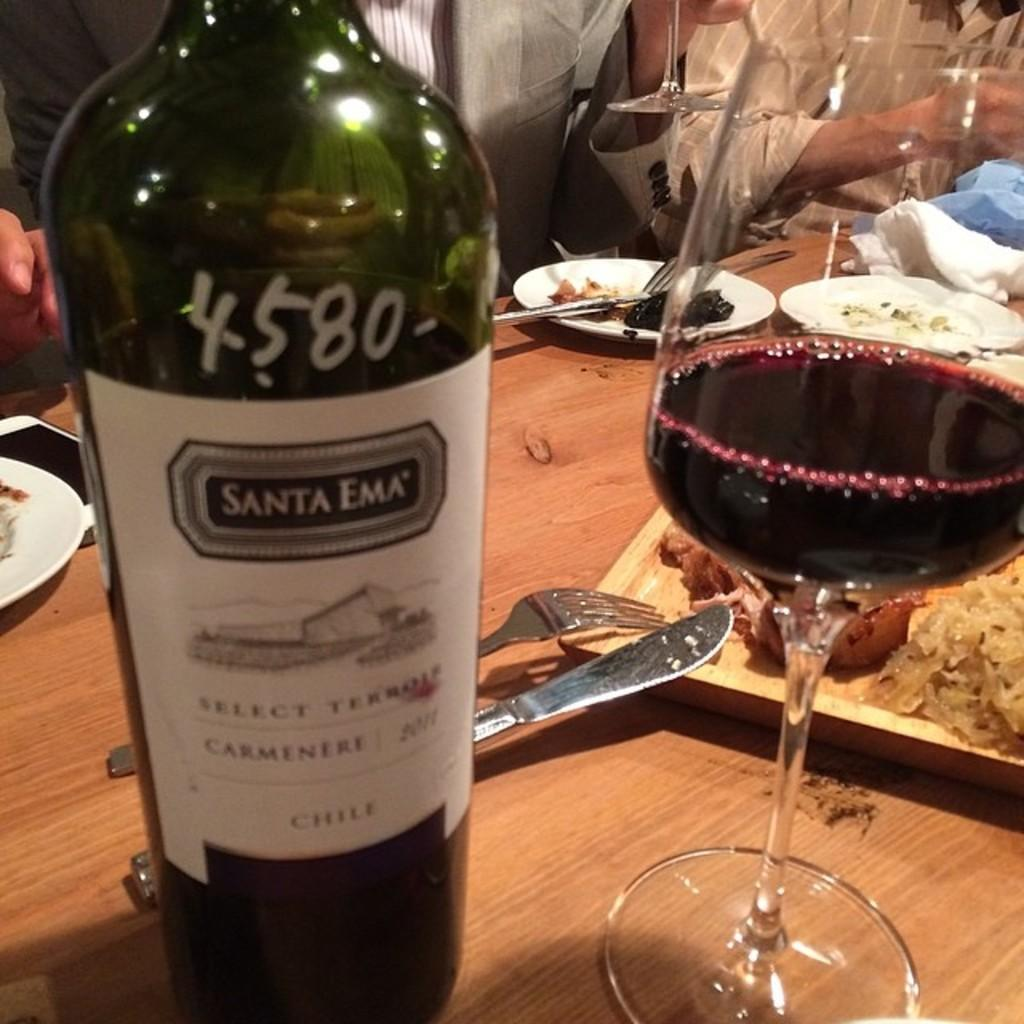<image>
Relay a brief, clear account of the picture shown. A glass of Santa Ema red wine is next to the bottle on a wooden dinner table. 